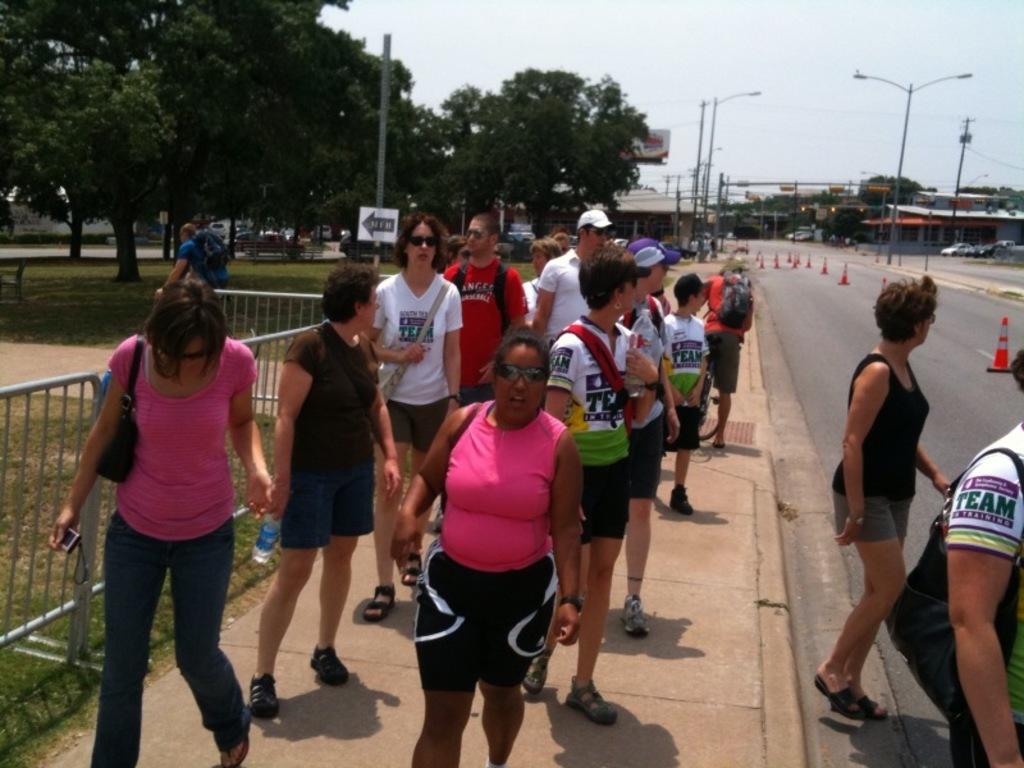In one or two sentences, can you explain what this image depicts? In this image there are persons standing and holding bags, camera and water bottle. There is a road, on road there are objects. And at the right side there are cars, building and street light. To the left side of the image there are trees, fence and man riding bicycle. And at the top there is a sky. 